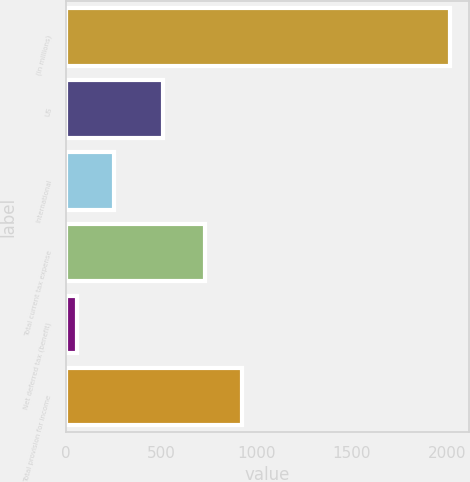Convert chart to OTSL. <chart><loc_0><loc_0><loc_500><loc_500><bar_chart><fcel>(in millions)<fcel>US<fcel>International<fcel>Total current tax expense<fcel>Net deferred tax (benefit)<fcel>Total provision for income<nl><fcel>2013<fcel>509<fcel>251.7<fcel>728<fcel>56<fcel>923.7<nl></chart> 